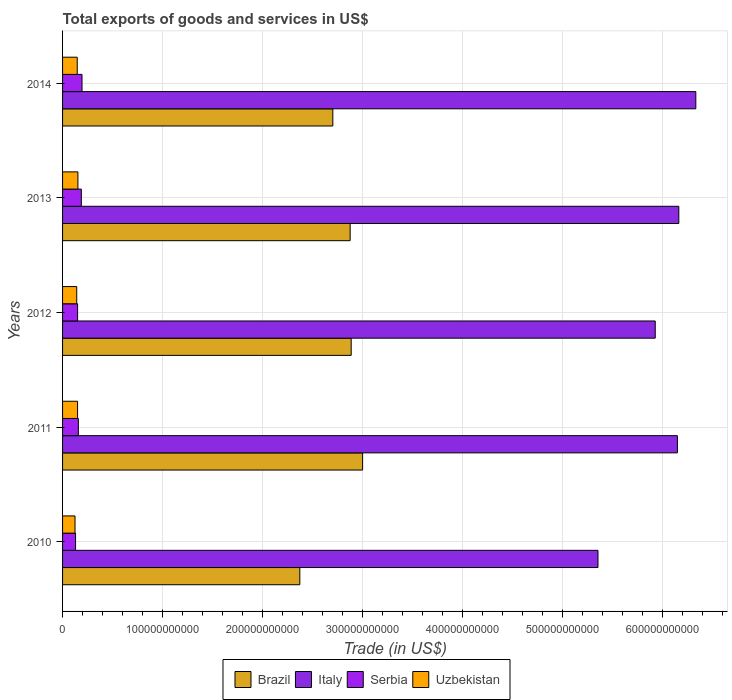Are the number of bars on each tick of the Y-axis equal?
Make the answer very short. Yes. How many bars are there on the 3rd tick from the bottom?
Make the answer very short. 4. In how many cases, is the number of bars for a given year not equal to the number of legend labels?
Your response must be concise. 0. What is the total exports of goods and services in Brazil in 2010?
Offer a terse response. 2.37e+11. Across all years, what is the maximum total exports of goods and services in Serbia?
Make the answer very short. 1.94e+1. Across all years, what is the minimum total exports of goods and services in Italy?
Make the answer very short. 5.35e+11. What is the total total exports of goods and services in Uzbekistan in the graph?
Your answer should be very brief. 7.16e+1. What is the difference between the total exports of goods and services in Serbia in 2010 and that in 2014?
Your response must be concise. -6.45e+09. What is the difference between the total exports of goods and services in Italy in 2011 and the total exports of goods and services in Brazil in 2012?
Offer a terse response. 3.26e+11. What is the average total exports of goods and services in Uzbekistan per year?
Offer a very short reply. 1.43e+1. In the year 2010, what is the difference between the total exports of goods and services in Serbia and total exports of goods and services in Uzbekistan?
Your response must be concise. 5.43e+08. In how many years, is the total exports of goods and services in Uzbekistan greater than 60000000000 US$?
Ensure brevity in your answer.  0. What is the ratio of the total exports of goods and services in Italy in 2013 to that in 2014?
Give a very brief answer. 0.97. Is the total exports of goods and services in Brazil in 2013 less than that in 2014?
Your response must be concise. No. Is the difference between the total exports of goods and services in Serbia in 2012 and 2013 greater than the difference between the total exports of goods and services in Uzbekistan in 2012 and 2013?
Your answer should be compact. No. What is the difference between the highest and the second highest total exports of goods and services in Serbia?
Offer a terse response. 6.94e+08. What is the difference between the highest and the lowest total exports of goods and services in Serbia?
Give a very brief answer. 6.45e+09. In how many years, is the total exports of goods and services in Uzbekistan greater than the average total exports of goods and services in Uzbekistan taken over all years?
Your response must be concise. 3. Is it the case that in every year, the sum of the total exports of goods and services in Serbia and total exports of goods and services in Brazil is greater than the sum of total exports of goods and services in Uzbekistan and total exports of goods and services in Italy?
Your answer should be very brief. Yes. What does the 4th bar from the top in 2010 represents?
Your response must be concise. Brazil. How many years are there in the graph?
Give a very brief answer. 5. What is the difference between two consecutive major ticks on the X-axis?
Provide a succinct answer. 1.00e+11. Where does the legend appear in the graph?
Give a very brief answer. Bottom center. How many legend labels are there?
Provide a succinct answer. 4. How are the legend labels stacked?
Ensure brevity in your answer.  Horizontal. What is the title of the graph?
Keep it short and to the point. Total exports of goods and services in US$. Does "Bosnia and Herzegovina" appear as one of the legend labels in the graph?
Provide a short and direct response. No. What is the label or title of the X-axis?
Your answer should be very brief. Trade (in US$). What is the Trade (in US$) in Brazil in 2010?
Provide a short and direct response. 2.37e+11. What is the Trade (in US$) in Italy in 2010?
Make the answer very short. 5.35e+11. What is the Trade (in US$) of Serbia in 2010?
Your answer should be very brief. 1.30e+1. What is the Trade (in US$) of Uzbekistan in 2010?
Give a very brief answer. 1.25e+1. What is the Trade (in US$) of Brazil in 2011?
Offer a very short reply. 3.00e+11. What is the Trade (in US$) in Italy in 2011?
Give a very brief answer. 6.15e+11. What is the Trade (in US$) in Serbia in 2011?
Provide a succinct answer. 1.58e+1. What is the Trade (in US$) of Uzbekistan in 2011?
Your answer should be very brief. 1.50e+1. What is the Trade (in US$) in Brazil in 2012?
Provide a short and direct response. 2.89e+11. What is the Trade (in US$) of Italy in 2012?
Provide a short and direct response. 5.93e+11. What is the Trade (in US$) in Serbia in 2012?
Offer a very short reply. 1.50e+1. What is the Trade (in US$) in Uzbekistan in 2012?
Provide a short and direct response. 1.42e+1. What is the Trade (in US$) of Brazil in 2013?
Your answer should be compact. 2.88e+11. What is the Trade (in US$) of Italy in 2013?
Your answer should be compact. 6.16e+11. What is the Trade (in US$) of Serbia in 2013?
Offer a terse response. 1.88e+1. What is the Trade (in US$) of Uzbekistan in 2013?
Your answer should be compact. 1.53e+1. What is the Trade (in US$) of Brazil in 2014?
Make the answer very short. 2.70e+11. What is the Trade (in US$) in Italy in 2014?
Your answer should be compact. 6.33e+11. What is the Trade (in US$) of Serbia in 2014?
Provide a succinct answer. 1.94e+1. What is the Trade (in US$) in Uzbekistan in 2014?
Provide a succinct answer. 1.47e+1. Across all years, what is the maximum Trade (in US$) in Brazil?
Your answer should be very brief. 3.00e+11. Across all years, what is the maximum Trade (in US$) of Italy?
Offer a terse response. 6.33e+11. Across all years, what is the maximum Trade (in US$) in Serbia?
Your answer should be compact. 1.94e+1. Across all years, what is the maximum Trade (in US$) in Uzbekistan?
Provide a succinct answer. 1.53e+1. Across all years, what is the minimum Trade (in US$) in Brazil?
Give a very brief answer. 2.37e+11. Across all years, what is the minimum Trade (in US$) in Italy?
Provide a short and direct response. 5.35e+11. Across all years, what is the minimum Trade (in US$) of Serbia?
Provide a short and direct response. 1.30e+1. Across all years, what is the minimum Trade (in US$) of Uzbekistan?
Give a very brief answer. 1.25e+1. What is the total Trade (in US$) in Brazil in the graph?
Give a very brief answer. 1.38e+12. What is the total Trade (in US$) of Italy in the graph?
Provide a succinct answer. 2.99e+12. What is the total Trade (in US$) of Serbia in the graph?
Provide a succinct answer. 8.20e+1. What is the total Trade (in US$) of Uzbekistan in the graph?
Your answer should be very brief. 7.16e+1. What is the difference between the Trade (in US$) of Brazil in 2010 and that in 2011?
Keep it short and to the point. -6.28e+1. What is the difference between the Trade (in US$) in Italy in 2010 and that in 2011?
Provide a succinct answer. -7.94e+1. What is the difference between the Trade (in US$) in Serbia in 2010 and that in 2011?
Provide a short and direct response. -2.79e+09. What is the difference between the Trade (in US$) of Uzbekistan in 2010 and that in 2011?
Give a very brief answer. -2.54e+09. What is the difference between the Trade (in US$) of Brazil in 2010 and that in 2012?
Make the answer very short. -5.14e+1. What is the difference between the Trade (in US$) in Italy in 2010 and that in 2012?
Ensure brevity in your answer.  -5.72e+1. What is the difference between the Trade (in US$) of Serbia in 2010 and that in 2012?
Make the answer very short. -2.05e+09. What is the difference between the Trade (in US$) in Uzbekistan in 2010 and that in 2012?
Offer a very short reply. -1.71e+09. What is the difference between the Trade (in US$) of Brazil in 2010 and that in 2013?
Make the answer very short. -5.03e+1. What is the difference between the Trade (in US$) in Italy in 2010 and that in 2013?
Ensure brevity in your answer.  -8.08e+1. What is the difference between the Trade (in US$) in Serbia in 2010 and that in 2013?
Ensure brevity in your answer.  -5.76e+09. What is the difference between the Trade (in US$) of Uzbekistan in 2010 and that in 2013?
Give a very brief answer. -2.89e+09. What is the difference between the Trade (in US$) in Brazil in 2010 and that in 2014?
Your answer should be compact. -3.30e+1. What is the difference between the Trade (in US$) in Italy in 2010 and that in 2014?
Provide a succinct answer. -9.78e+1. What is the difference between the Trade (in US$) of Serbia in 2010 and that in 2014?
Keep it short and to the point. -6.45e+09. What is the difference between the Trade (in US$) in Uzbekistan in 2010 and that in 2014?
Ensure brevity in your answer.  -2.21e+09. What is the difference between the Trade (in US$) in Brazil in 2011 and that in 2012?
Your answer should be very brief. 1.14e+1. What is the difference between the Trade (in US$) in Italy in 2011 and that in 2012?
Provide a short and direct response. 2.22e+1. What is the difference between the Trade (in US$) of Serbia in 2011 and that in 2012?
Provide a short and direct response. 7.42e+08. What is the difference between the Trade (in US$) of Uzbekistan in 2011 and that in 2012?
Ensure brevity in your answer.  8.28e+08. What is the difference between the Trade (in US$) in Brazil in 2011 and that in 2013?
Offer a terse response. 1.25e+1. What is the difference between the Trade (in US$) of Italy in 2011 and that in 2013?
Keep it short and to the point. -1.40e+09. What is the difference between the Trade (in US$) of Serbia in 2011 and that in 2013?
Your response must be concise. -2.97e+09. What is the difference between the Trade (in US$) of Uzbekistan in 2011 and that in 2013?
Provide a succinct answer. -3.52e+08. What is the difference between the Trade (in US$) of Brazil in 2011 and that in 2014?
Your answer should be very brief. 2.98e+1. What is the difference between the Trade (in US$) in Italy in 2011 and that in 2014?
Make the answer very short. -1.84e+1. What is the difference between the Trade (in US$) of Serbia in 2011 and that in 2014?
Make the answer very short. -3.66e+09. What is the difference between the Trade (in US$) of Uzbekistan in 2011 and that in 2014?
Make the answer very short. 3.31e+08. What is the difference between the Trade (in US$) in Brazil in 2012 and that in 2013?
Offer a terse response. 1.03e+09. What is the difference between the Trade (in US$) of Italy in 2012 and that in 2013?
Give a very brief answer. -2.36e+1. What is the difference between the Trade (in US$) of Serbia in 2012 and that in 2013?
Keep it short and to the point. -3.71e+09. What is the difference between the Trade (in US$) of Uzbekistan in 2012 and that in 2013?
Provide a short and direct response. -1.18e+09. What is the difference between the Trade (in US$) of Brazil in 2012 and that in 2014?
Keep it short and to the point. 1.83e+1. What is the difference between the Trade (in US$) in Italy in 2012 and that in 2014?
Your answer should be compact. -4.06e+1. What is the difference between the Trade (in US$) in Serbia in 2012 and that in 2014?
Offer a very short reply. -4.40e+09. What is the difference between the Trade (in US$) in Uzbekistan in 2012 and that in 2014?
Your answer should be very brief. -4.97e+08. What is the difference between the Trade (in US$) of Brazil in 2013 and that in 2014?
Ensure brevity in your answer.  1.73e+1. What is the difference between the Trade (in US$) of Italy in 2013 and that in 2014?
Your response must be concise. -1.70e+1. What is the difference between the Trade (in US$) in Serbia in 2013 and that in 2014?
Ensure brevity in your answer.  -6.94e+08. What is the difference between the Trade (in US$) in Uzbekistan in 2013 and that in 2014?
Keep it short and to the point. 6.83e+08. What is the difference between the Trade (in US$) of Brazil in 2010 and the Trade (in US$) of Italy in 2011?
Offer a terse response. -3.78e+11. What is the difference between the Trade (in US$) in Brazil in 2010 and the Trade (in US$) in Serbia in 2011?
Offer a very short reply. 2.21e+11. What is the difference between the Trade (in US$) in Brazil in 2010 and the Trade (in US$) in Uzbekistan in 2011?
Offer a very short reply. 2.22e+11. What is the difference between the Trade (in US$) in Italy in 2010 and the Trade (in US$) in Serbia in 2011?
Your response must be concise. 5.20e+11. What is the difference between the Trade (in US$) in Italy in 2010 and the Trade (in US$) in Uzbekistan in 2011?
Offer a terse response. 5.20e+11. What is the difference between the Trade (in US$) of Serbia in 2010 and the Trade (in US$) of Uzbekistan in 2011?
Offer a very short reply. -2.00e+09. What is the difference between the Trade (in US$) in Brazil in 2010 and the Trade (in US$) in Italy in 2012?
Offer a terse response. -3.55e+11. What is the difference between the Trade (in US$) in Brazil in 2010 and the Trade (in US$) in Serbia in 2012?
Keep it short and to the point. 2.22e+11. What is the difference between the Trade (in US$) of Brazil in 2010 and the Trade (in US$) of Uzbekistan in 2012?
Provide a short and direct response. 2.23e+11. What is the difference between the Trade (in US$) of Italy in 2010 and the Trade (in US$) of Serbia in 2012?
Your answer should be compact. 5.20e+11. What is the difference between the Trade (in US$) in Italy in 2010 and the Trade (in US$) in Uzbekistan in 2012?
Keep it short and to the point. 5.21e+11. What is the difference between the Trade (in US$) in Serbia in 2010 and the Trade (in US$) in Uzbekistan in 2012?
Keep it short and to the point. -1.17e+09. What is the difference between the Trade (in US$) of Brazil in 2010 and the Trade (in US$) of Italy in 2013?
Keep it short and to the point. -3.79e+11. What is the difference between the Trade (in US$) of Brazil in 2010 and the Trade (in US$) of Serbia in 2013?
Ensure brevity in your answer.  2.18e+11. What is the difference between the Trade (in US$) in Brazil in 2010 and the Trade (in US$) in Uzbekistan in 2013?
Your answer should be very brief. 2.22e+11. What is the difference between the Trade (in US$) of Italy in 2010 and the Trade (in US$) of Serbia in 2013?
Provide a succinct answer. 5.17e+11. What is the difference between the Trade (in US$) in Italy in 2010 and the Trade (in US$) in Uzbekistan in 2013?
Your answer should be compact. 5.20e+11. What is the difference between the Trade (in US$) in Serbia in 2010 and the Trade (in US$) in Uzbekistan in 2013?
Keep it short and to the point. -2.35e+09. What is the difference between the Trade (in US$) in Brazil in 2010 and the Trade (in US$) in Italy in 2014?
Your answer should be very brief. -3.96e+11. What is the difference between the Trade (in US$) in Brazil in 2010 and the Trade (in US$) in Serbia in 2014?
Offer a very short reply. 2.18e+11. What is the difference between the Trade (in US$) in Brazil in 2010 and the Trade (in US$) in Uzbekistan in 2014?
Ensure brevity in your answer.  2.23e+11. What is the difference between the Trade (in US$) of Italy in 2010 and the Trade (in US$) of Serbia in 2014?
Make the answer very short. 5.16e+11. What is the difference between the Trade (in US$) of Italy in 2010 and the Trade (in US$) of Uzbekistan in 2014?
Your answer should be compact. 5.21e+11. What is the difference between the Trade (in US$) of Serbia in 2010 and the Trade (in US$) of Uzbekistan in 2014?
Keep it short and to the point. -1.67e+09. What is the difference between the Trade (in US$) in Brazil in 2011 and the Trade (in US$) in Italy in 2012?
Make the answer very short. -2.93e+11. What is the difference between the Trade (in US$) in Brazil in 2011 and the Trade (in US$) in Serbia in 2012?
Your answer should be very brief. 2.85e+11. What is the difference between the Trade (in US$) in Brazil in 2011 and the Trade (in US$) in Uzbekistan in 2012?
Keep it short and to the point. 2.86e+11. What is the difference between the Trade (in US$) of Italy in 2011 and the Trade (in US$) of Serbia in 2012?
Provide a succinct answer. 6.00e+11. What is the difference between the Trade (in US$) in Italy in 2011 and the Trade (in US$) in Uzbekistan in 2012?
Provide a short and direct response. 6.01e+11. What is the difference between the Trade (in US$) in Serbia in 2011 and the Trade (in US$) in Uzbekistan in 2012?
Offer a terse response. 1.62e+09. What is the difference between the Trade (in US$) in Brazil in 2011 and the Trade (in US$) in Italy in 2013?
Offer a very short reply. -3.16e+11. What is the difference between the Trade (in US$) of Brazil in 2011 and the Trade (in US$) of Serbia in 2013?
Offer a very short reply. 2.81e+11. What is the difference between the Trade (in US$) in Brazil in 2011 and the Trade (in US$) in Uzbekistan in 2013?
Offer a terse response. 2.85e+11. What is the difference between the Trade (in US$) of Italy in 2011 and the Trade (in US$) of Serbia in 2013?
Make the answer very short. 5.96e+11. What is the difference between the Trade (in US$) in Italy in 2011 and the Trade (in US$) in Uzbekistan in 2013?
Provide a short and direct response. 5.99e+11. What is the difference between the Trade (in US$) of Serbia in 2011 and the Trade (in US$) of Uzbekistan in 2013?
Keep it short and to the point. 4.42e+08. What is the difference between the Trade (in US$) of Brazil in 2011 and the Trade (in US$) of Italy in 2014?
Offer a terse response. -3.33e+11. What is the difference between the Trade (in US$) of Brazil in 2011 and the Trade (in US$) of Serbia in 2014?
Provide a succinct answer. 2.81e+11. What is the difference between the Trade (in US$) in Brazil in 2011 and the Trade (in US$) in Uzbekistan in 2014?
Keep it short and to the point. 2.85e+11. What is the difference between the Trade (in US$) in Italy in 2011 and the Trade (in US$) in Serbia in 2014?
Make the answer very short. 5.95e+11. What is the difference between the Trade (in US$) of Italy in 2011 and the Trade (in US$) of Uzbekistan in 2014?
Your answer should be very brief. 6.00e+11. What is the difference between the Trade (in US$) in Serbia in 2011 and the Trade (in US$) in Uzbekistan in 2014?
Offer a terse response. 1.12e+09. What is the difference between the Trade (in US$) of Brazil in 2012 and the Trade (in US$) of Italy in 2013?
Offer a very short reply. -3.28e+11. What is the difference between the Trade (in US$) in Brazil in 2012 and the Trade (in US$) in Serbia in 2013?
Your answer should be very brief. 2.70e+11. What is the difference between the Trade (in US$) in Brazil in 2012 and the Trade (in US$) in Uzbekistan in 2013?
Give a very brief answer. 2.73e+11. What is the difference between the Trade (in US$) of Italy in 2012 and the Trade (in US$) of Serbia in 2013?
Offer a very short reply. 5.74e+11. What is the difference between the Trade (in US$) in Italy in 2012 and the Trade (in US$) in Uzbekistan in 2013?
Offer a terse response. 5.77e+11. What is the difference between the Trade (in US$) of Serbia in 2012 and the Trade (in US$) of Uzbekistan in 2013?
Provide a succinct answer. -3.00e+08. What is the difference between the Trade (in US$) of Brazil in 2012 and the Trade (in US$) of Italy in 2014?
Offer a terse response. -3.45e+11. What is the difference between the Trade (in US$) in Brazil in 2012 and the Trade (in US$) in Serbia in 2014?
Your answer should be very brief. 2.69e+11. What is the difference between the Trade (in US$) in Brazil in 2012 and the Trade (in US$) in Uzbekistan in 2014?
Give a very brief answer. 2.74e+11. What is the difference between the Trade (in US$) of Italy in 2012 and the Trade (in US$) of Serbia in 2014?
Keep it short and to the point. 5.73e+11. What is the difference between the Trade (in US$) in Italy in 2012 and the Trade (in US$) in Uzbekistan in 2014?
Ensure brevity in your answer.  5.78e+11. What is the difference between the Trade (in US$) of Serbia in 2012 and the Trade (in US$) of Uzbekistan in 2014?
Your response must be concise. 3.82e+08. What is the difference between the Trade (in US$) in Brazil in 2013 and the Trade (in US$) in Italy in 2014?
Offer a terse response. -3.46e+11. What is the difference between the Trade (in US$) of Brazil in 2013 and the Trade (in US$) of Serbia in 2014?
Offer a terse response. 2.68e+11. What is the difference between the Trade (in US$) of Brazil in 2013 and the Trade (in US$) of Uzbekistan in 2014?
Ensure brevity in your answer.  2.73e+11. What is the difference between the Trade (in US$) in Italy in 2013 and the Trade (in US$) in Serbia in 2014?
Your answer should be very brief. 5.97e+11. What is the difference between the Trade (in US$) of Italy in 2013 and the Trade (in US$) of Uzbekistan in 2014?
Provide a short and direct response. 6.01e+11. What is the difference between the Trade (in US$) of Serbia in 2013 and the Trade (in US$) of Uzbekistan in 2014?
Make the answer very short. 4.09e+09. What is the average Trade (in US$) of Brazil per year?
Offer a terse response. 2.77e+11. What is the average Trade (in US$) in Italy per year?
Your answer should be very brief. 5.98e+11. What is the average Trade (in US$) of Serbia per year?
Keep it short and to the point. 1.64e+1. What is the average Trade (in US$) in Uzbekistan per year?
Your answer should be very brief. 1.43e+1. In the year 2010, what is the difference between the Trade (in US$) in Brazil and Trade (in US$) in Italy?
Provide a succinct answer. -2.98e+11. In the year 2010, what is the difference between the Trade (in US$) of Brazil and Trade (in US$) of Serbia?
Provide a short and direct response. 2.24e+11. In the year 2010, what is the difference between the Trade (in US$) of Brazil and Trade (in US$) of Uzbekistan?
Ensure brevity in your answer.  2.25e+11. In the year 2010, what is the difference between the Trade (in US$) of Italy and Trade (in US$) of Serbia?
Give a very brief answer. 5.22e+11. In the year 2010, what is the difference between the Trade (in US$) of Italy and Trade (in US$) of Uzbekistan?
Make the answer very short. 5.23e+11. In the year 2010, what is the difference between the Trade (in US$) in Serbia and Trade (in US$) in Uzbekistan?
Your answer should be very brief. 5.43e+08. In the year 2011, what is the difference between the Trade (in US$) in Brazil and Trade (in US$) in Italy?
Offer a terse response. -3.15e+11. In the year 2011, what is the difference between the Trade (in US$) of Brazil and Trade (in US$) of Serbia?
Ensure brevity in your answer.  2.84e+11. In the year 2011, what is the difference between the Trade (in US$) in Brazil and Trade (in US$) in Uzbekistan?
Offer a very short reply. 2.85e+11. In the year 2011, what is the difference between the Trade (in US$) of Italy and Trade (in US$) of Serbia?
Offer a very short reply. 5.99e+11. In the year 2011, what is the difference between the Trade (in US$) in Italy and Trade (in US$) in Uzbekistan?
Offer a terse response. 6.00e+11. In the year 2011, what is the difference between the Trade (in US$) of Serbia and Trade (in US$) of Uzbekistan?
Ensure brevity in your answer.  7.94e+08. In the year 2012, what is the difference between the Trade (in US$) of Brazil and Trade (in US$) of Italy?
Ensure brevity in your answer.  -3.04e+11. In the year 2012, what is the difference between the Trade (in US$) in Brazil and Trade (in US$) in Serbia?
Give a very brief answer. 2.74e+11. In the year 2012, what is the difference between the Trade (in US$) in Brazil and Trade (in US$) in Uzbekistan?
Your answer should be compact. 2.74e+11. In the year 2012, what is the difference between the Trade (in US$) in Italy and Trade (in US$) in Serbia?
Provide a short and direct response. 5.77e+11. In the year 2012, what is the difference between the Trade (in US$) in Italy and Trade (in US$) in Uzbekistan?
Give a very brief answer. 5.78e+11. In the year 2012, what is the difference between the Trade (in US$) of Serbia and Trade (in US$) of Uzbekistan?
Ensure brevity in your answer.  8.80e+08. In the year 2013, what is the difference between the Trade (in US$) of Brazil and Trade (in US$) of Italy?
Ensure brevity in your answer.  -3.29e+11. In the year 2013, what is the difference between the Trade (in US$) in Brazil and Trade (in US$) in Serbia?
Keep it short and to the point. 2.69e+11. In the year 2013, what is the difference between the Trade (in US$) in Brazil and Trade (in US$) in Uzbekistan?
Your response must be concise. 2.72e+11. In the year 2013, what is the difference between the Trade (in US$) of Italy and Trade (in US$) of Serbia?
Give a very brief answer. 5.97e+11. In the year 2013, what is the difference between the Trade (in US$) of Italy and Trade (in US$) of Uzbekistan?
Your response must be concise. 6.01e+11. In the year 2013, what is the difference between the Trade (in US$) in Serbia and Trade (in US$) in Uzbekistan?
Keep it short and to the point. 3.41e+09. In the year 2014, what is the difference between the Trade (in US$) of Brazil and Trade (in US$) of Italy?
Provide a succinct answer. -3.63e+11. In the year 2014, what is the difference between the Trade (in US$) of Brazil and Trade (in US$) of Serbia?
Your answer should be compact. 2.51e+11. In the year 2014, what is the difference between the Trade (in US$) in Brazil and Trade (in US$) in Uzbekistan?
Your answer should be compact. 2.56e+11. In the year 2014, what is the difference between the Trade (in US$) in Italy and Trade (in US$) in Serbia?
Offer a very short reply. 6.14e+11. In the year 2014, what is the difference between the Trade (in US$) of Italy and Trade (in US$) of Uzbekistan?
Offer a very short reply. 6.18e+11. In the year 2014, what is the difference between the Trade (in US$) of Serbia and Trade (in US$) of Uzbekistan?
Offer a terse response. 4.79e+09. What is the ratio of the Trade (in US$) in Brazil in 2010 to that in 2011?
Ensure brevity in your answer.  0.79. What is the ratio of the Trade (in US$) of Italy in 2010 to that in 2011?
Your answer should be compact. 0.87. What is the ratio of the Trade (in US$) of Serbia in 2010 to that in 2011?
Ensure brevity in your answer.  0.82. What is the ratio of the Trade (in US$) of Uzbekistan in 2010 to that in 2011?
Make the answer very short. 0.83. What is the ratio of the Trade (in US$) in Brazil in 2010 to that in 2012?
Ensure brevity in your answer.  0.82. What is the ratio of the Trade (in US$) in Italy in 2010 to that in 2012?
Make the answer very short. 0.9. What is the ratio of the Trade (in US$) in Serbia in 2010 to that in 2012?
Give a very brief answer. 0.86. What is the ratio of the Trade (in US$) of Uzbekistan in 2010 to that in 2012?
Make the answer very short. 0.88. What is the ratio of the Trade (in US$) in Brazil in 2010 to that in 2013?
Your response must be concise. 0.82. What is the ratio of the Trade (in US$) in Italy in 2010 to that in 2013?
Your answer should be compact. 0.87. What is the ratio of the Trade (in US$) of Serbia in 2010 to that in 2013?
Your response must be concise. 0.69. What is the ratio of the Trade (in US$) in Uzbekistan in 2010 to that in 2013?
Offer a terse response. 0.81. What is the ratio of the Trade (in US$) in Brazil in 2010 to that in 2014?
Provide a short and direct response. 0.88. What is the ratio of the Trade (in US$) of Italy in 2010 to that in 2014?
Offer a terse response. 0.85. What is the ratio of the Trade (in US$) in Serbia in 2010 to that in 2014?
Offer a very short reply. 0.67. What is the ratio of the Trade (in US$) of Uzbekistan in 2010 to that in 2014?
Keep it short and to the point. 0.85. What is the ratio of the Trade (in US$) in Brazil in 2011 to that in 2012?
Your response must be concise. 1.04. What is the ratio of the Trade (in US$) in Italy in 2011 to that in 2012?
Offer a terse response. 1.04. What is the ratio of the Trade (in US$) in Serbia in 2011 to that in 2012?
Ensure brevity in your answer.  1.05. What is the ratio of the Trade (in US$) in Uzbekistan in 2011 to that in 2012?
Ensure brevity in your answer.  1.06. What is the ratio of the Trade (in US$) in Brazil in 2011 to that in 2013?
Offer a very short reply. 1.04. What is the ratio of the Trade (in US$) in Serbia in 2011 to that in 2013?
Offer a very short reply. 0.84. What is the ratio of the Trade (in US$) of Uzbekistan in 2011 to that in 2013?
Your answer should be compact. 0.98. What is the ratio of the Trade (in US$) in Brazil in 2011 to that in 2014?
Make the answer very short. 1.11. What is the ratio of the Trade (in US$) in Italy in 2011 to that in 2014?
Ensure brevity in your answer.  0.97. What is the ratio of the Trade (in US$) in Serbia in 2011 to that in 2014?
Your answer should be compact. 0.81. What is the ratio of the Trade (in US$) in Uzbekistan in 2011 to that in 2014?
Give a very brief answer. 1.02. What is the ratio of the Trade (in US$) in Brazil in 2012 to that in 2013?
Make the answer very short. 1. What is the ratio of the Trade (in US$) in Italy in 2012 to that in 2013?
Keep it short and to the point. 0.96. What is the ratio of the Trade (in US$) in Serbia in 2012 to that in 2013?
Provide a succinct answer. 0.8. What is the ratio of the Trade (in US$) of Brazil in 2012 to that in 2014?
Offer a terse response. 1.07. What is the ratio of the Trade (in US$) in Italy in 2012 to that in 2014?
Keep it short and to the point. 0.94. What is the ratio of the Trade (in US$) of Serbia in 2012 to that in 2014?
Make the answer very short. 0.77. What is the ratio of the Trade (in US$) in Uzbekistan in 2012 to that in 2014?
Your response must be concise. 0.97. What is the ratio of the Trade (in US$) in Brazil in 2013 to that in 2014?
Provide a short and direct response. 1.06. What is the ratio of the Trade (in US$) of Italy in 2013 to that in 2014?
Your response must be concise. 0.97. What is the ratio of the Trade (in US$) in Uzbekistan in 2013 to that in 2014?
Provide a short and direct response. 1.05. What is the difference between the highest and the second highest Trade (in US$) of Brazil?
Your answer should be very brief. 1.14e+1. What is the difference between the highest and the second highest Trade (in US$) of Italy?
Provide a short and direct response. 1.70e+1. What is the difference between the highest and the second highest Trade (in US$) in Serbia?
Provide a succinct answer. 6.94e+08. What is the difference between the highest and the second highest Trade (in US$) in Uzbekistan?
Provide a succinct answer. 3.52e+08. What is the difference between the highest and the lowest Trade (in US$) in Brazil?
Ensure brevity in your answer.  6.28e+1. What is the difference between the highest and the lowest Trade (in US$) in Italy?
Provide a short and direct response. 9.78e+1. What is the difference between the highest and the lowest Trade (in US$) of Serbia?
Make the answer very short. 6.45e+09. What is the difference between the highest and the lowest Trade (in US$) in Uzbekistan?
Give a very brief answer. 2.89e+09. 